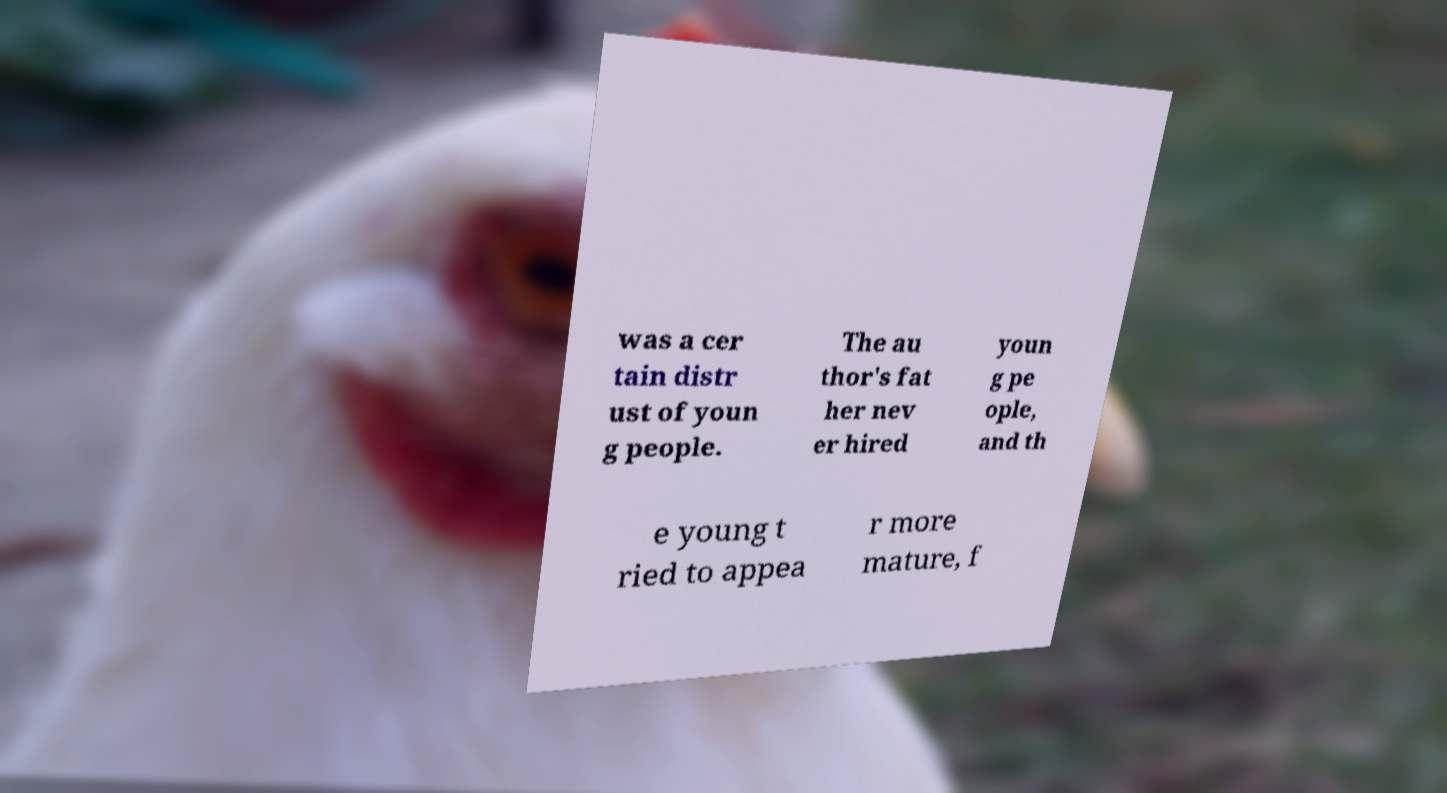What messages or text are displayed in this image? I need them in a readable, typed format. was a cer tain distr ust of youn g people. The au thor's fat her nev er hired youn g pe ople, and th e young t ried to appea r more mature, f 